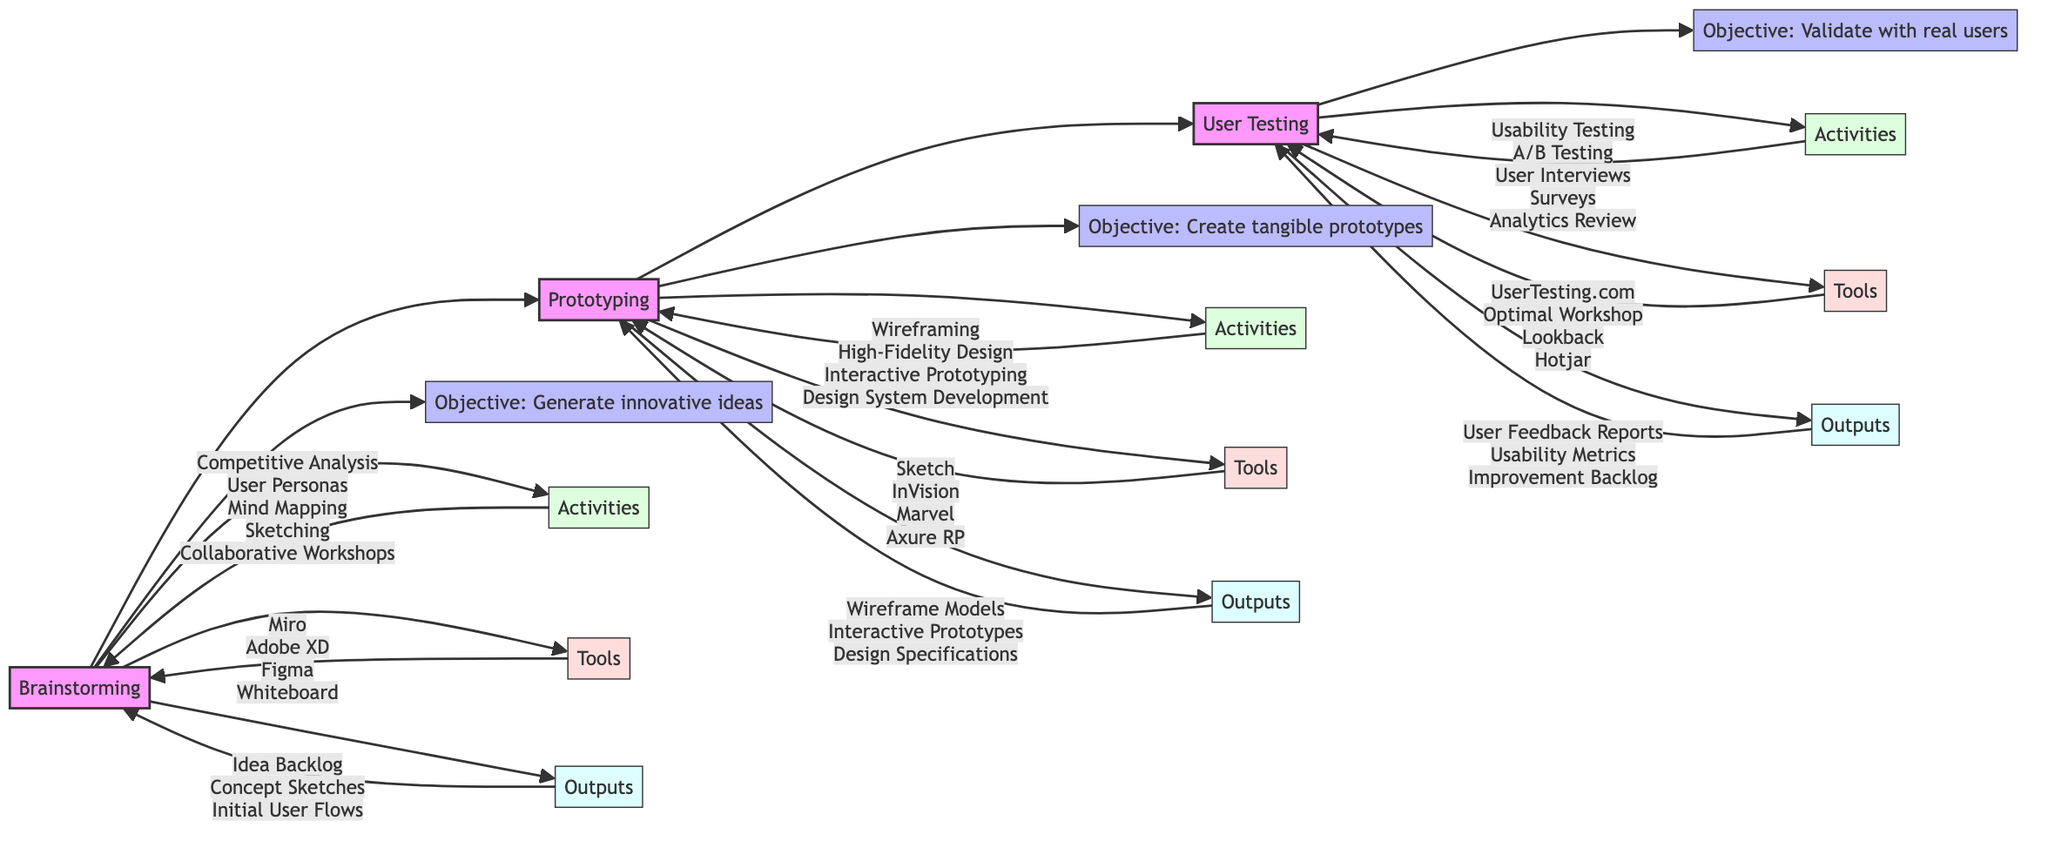What is the objective of the Brainstorming phase? The Brainstorming phase has a specific objective listed directly as "Generate innovative ideas that push beyond conventional boundaries." which can be found in the corresponding consideration node connected to the Brainstorming phase.
Answer: Generate innovative ideas How many outputs are there in the Prototyping phase? In the Prototyping phase, there are three outputs  listed: "Wireframe Models", "Interactive Prototypes", and "Design Specifications". Therefore, counting these gives a total of three outputs.
Answer: 3 What is the last phase in the flowchart? The last phase in the flowchart is User Testing, which is evident as it follows the Prototyping phase and has no further connections leading from it.
Answer: User Testing Which tool is used in the User Testing phase for analytics review? In the User Testing phase, the tool specified for analytics review is "Hotjar", which can be found directly under the Tools node connected to the User Testing phase.
Answer: Hotjar What activity comes after Prototyping? Following the Prototyping phase, the next phase is User Testing, as represented by the directed arrow that connects Prototyping to User Testing in the flowchart.
Answer: User Testing What are the activities listed in the Brainstorming phase? The activities in the Brainstorming phase include "Competitive Analysis", "User Personas", "Mind Mapping", "Sketching", and "Collaborative Workshops", all of which are enumerated under the Activities node connected to Brainstorming.
Answer: Competitive Analysis, User Personas, Mind Mapping, Sketching, Collaborative Workshops How many tools are listed in the Prototyping phase? There are four tools listed for the Prototyping phase: "Sketch", "InVision", "Marvel", and "Axure RP". This can be counted directly from the Tools node of the Prototyping phase.
Answer: 4 What is the relationship between Prototyping and User Testing? The relationship between Prototyping and User Testing is that User Testing is a direct progression or next step, indicated by an arrow connecting Prototyping to User Testing in the flowchart.
Answer: User Testing is next What is the main focus of the User Testing phase? The main focus of the User Testing phase is to "Validate the prototypes with real users to gather actionable feedback." which is clearly stated in the objective section connected to the User Testing phase.
Answer: Validate the prototypes with real users 